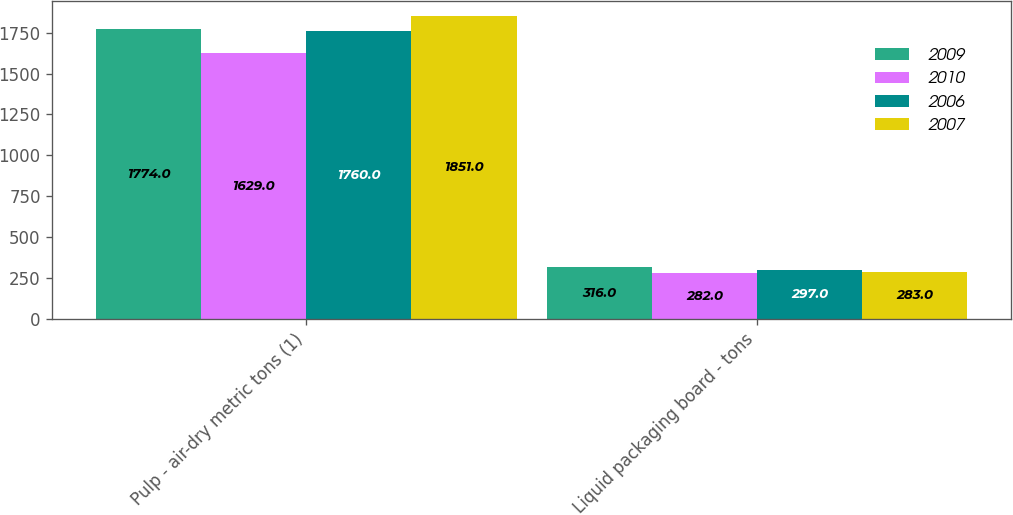<chart> <loc_0><loc_0><loc_500><loc_500><stacked_bar_chart><ecel><fcel>Pulp - air-dry metric tons (1)<fcel>Liquid packaging board - tons<nl><fcel>2009<fcel>1774<fcel>316<nl><fcel>2010<fcel>1629<fcel>282<nl><fcel>2006<fcel>1760<fcel>297<nl><fcel>2007<fcel>1851<fcel>283<nl></chart> 